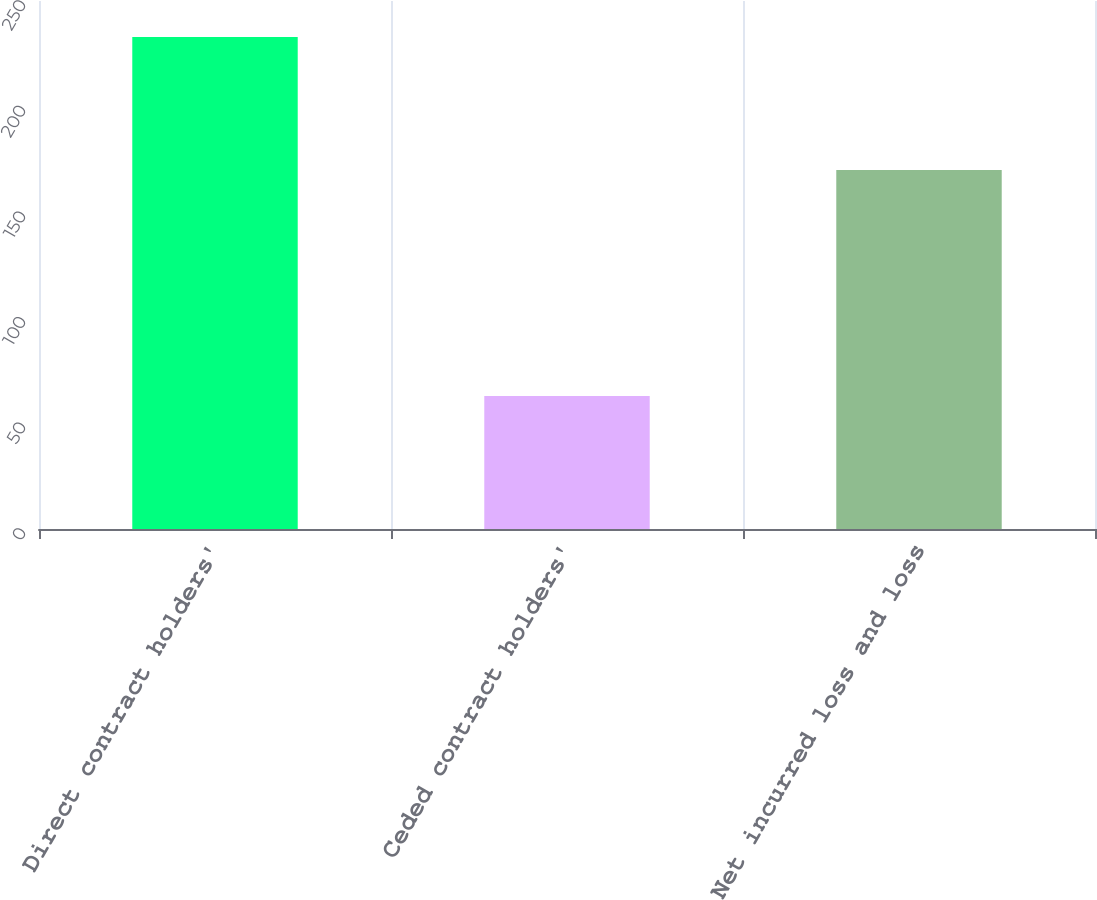<chart> <loc_0><loc_0><loc_500><loc_500><bar_chart><fcel>Direct contract holders'<fcel>Ceded contract holders'<fcel>Net incurred loss and loss<nl><fcel>233<fcel>63<fcel>170<nl></chart> 